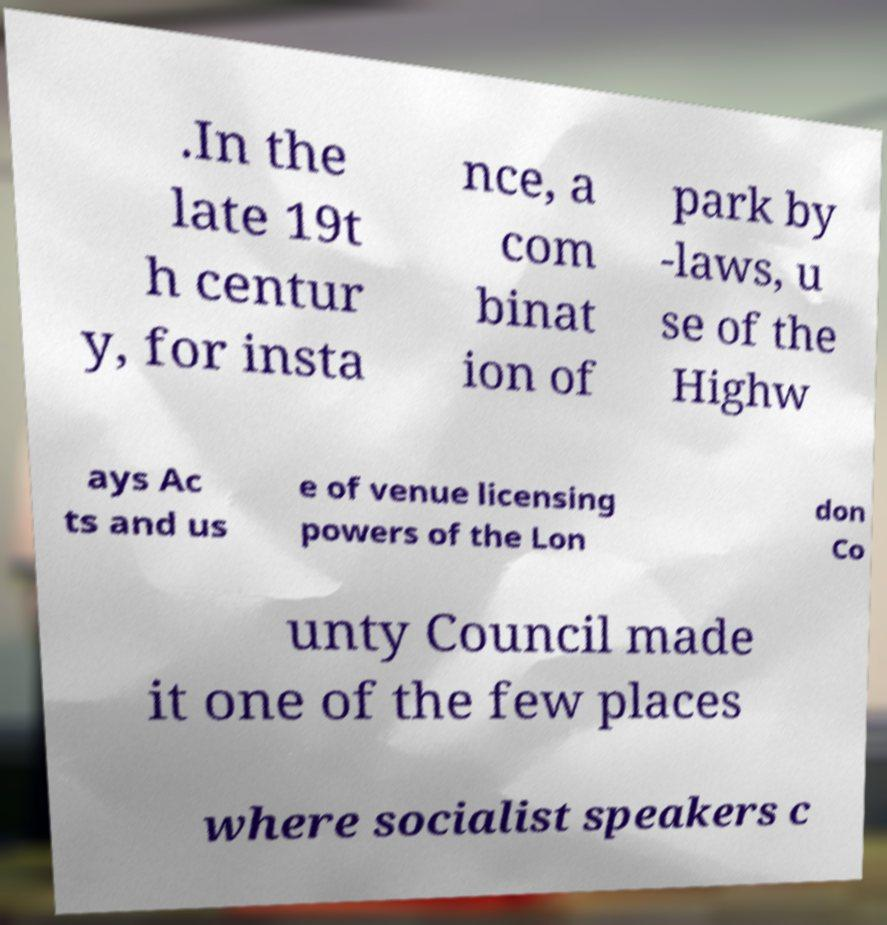I need the written content from this picture converted into text. Can you do that? .In the late 19t h centur y, for insta nce, a com binat ion of park by -laws, u se of the Highw ays Ac ts and us e of venue licensing powers of the Lon don Co unty Council made it one of the few places where socialist speakers c 